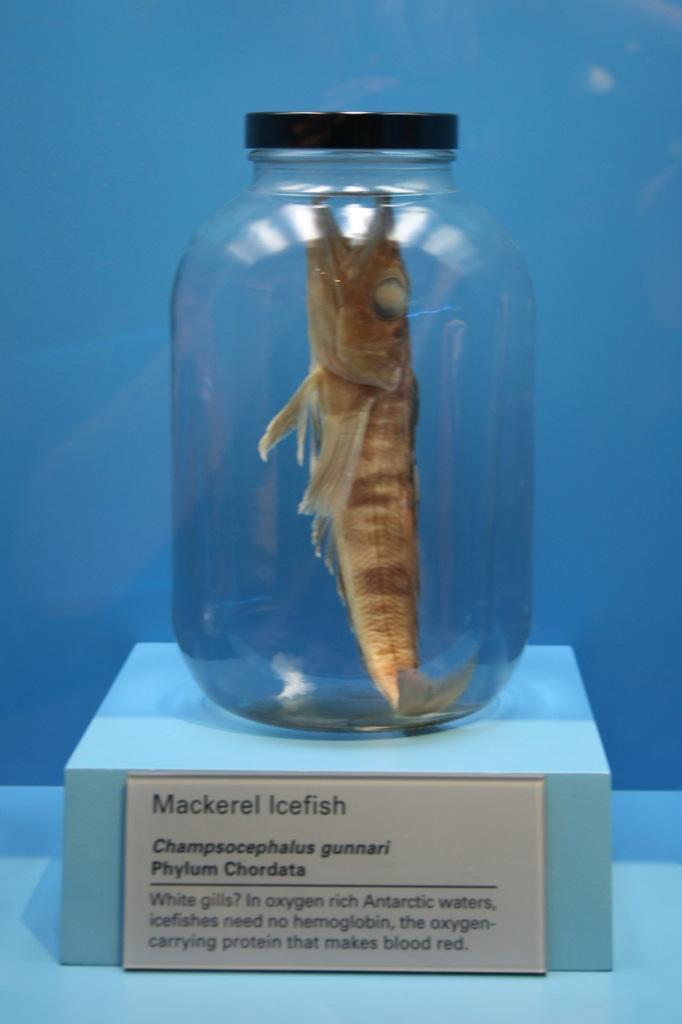In one or two sentences, can you explain what this image depicts? In this image there is fish is putting in the bottle and the bottle is keeping on the cardboard and the background is bluish in color and some text is there on the card board. 